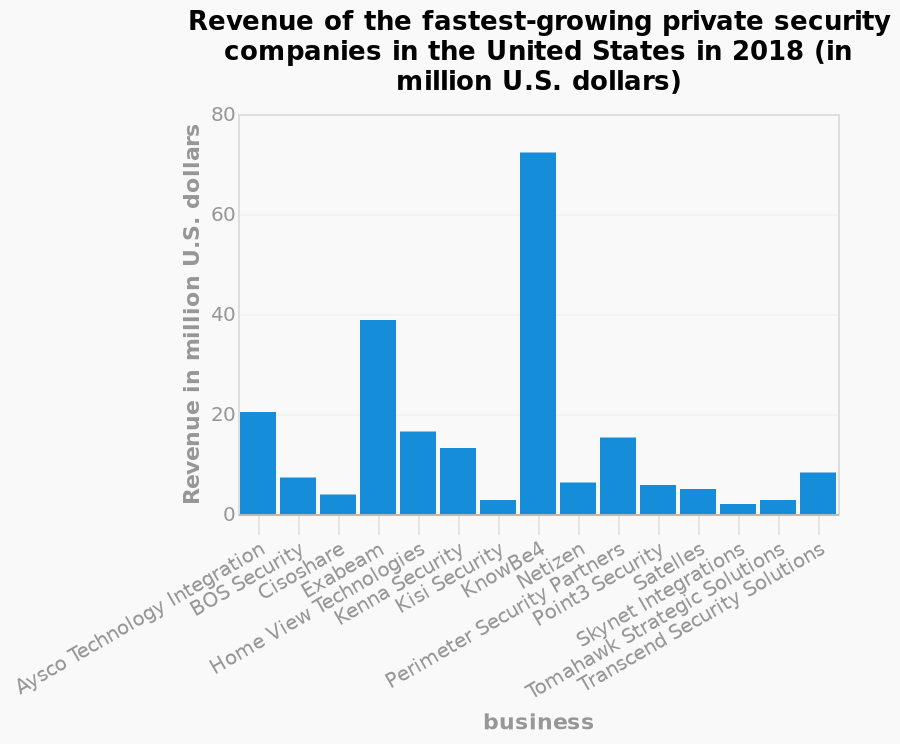<image>
How does the revenue of Knowbe4 compare to the smallest company's revenue? Knowbe4 generated more than 3 times the revenue of the smallest company in the group. What is the name of the smallest company in terms of revenue? The smallest company in terms of revenue is Aysco Technology Integration.  What is the minimum value on the y-axis of the bar plot?  The minimum value on the y-axis of the bar plot is 0 million U.S. dollars. Is the maximum value on the y-axis of the bar plot 0 million U.S. dollars? No. The minimum value on the y-axis of the bar plot is 0 million U.S. dollars. 